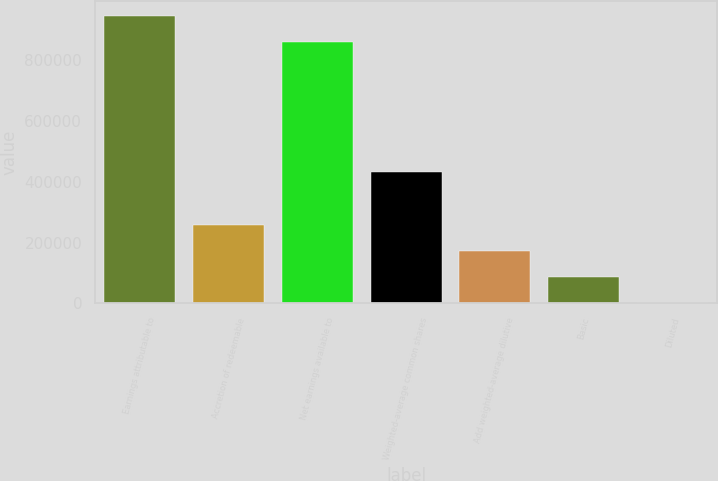Convert chart. <chart><loc_0><loc_0><loc_500><loc_500><bar_chart><fcel>Earnings attributable to<fcel>Accretion of redeemable<fcel>Net earnings available to<fcel>Weighted-average common shares<fcel>Add weighted-average dilutive<fcel>Basic<fcel>Diluted<nl><fcel>943981<fcel>258519<fcel>857812<fcel>430858<fcel>172350<fcel>86180.7<fcel>11.47<nl></chart> 